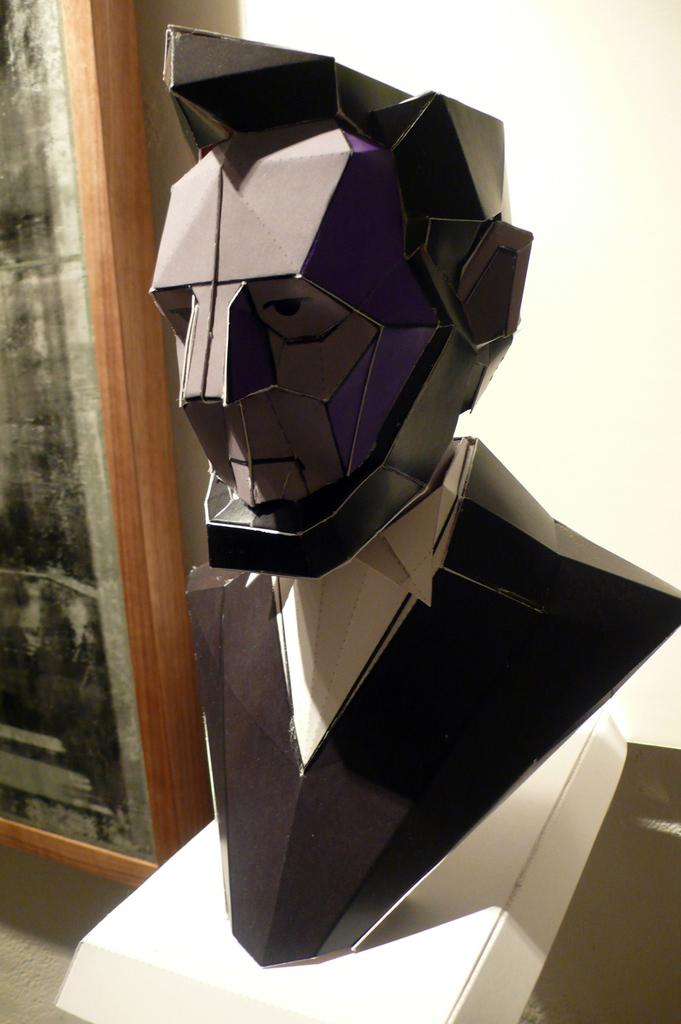What is the main subject in the image? There is a statue of a person in the image. What is the color scheme of the statue? The statue is in black and white color. What can be seen in the background of the image? There is a board and a wall in the background of the image. What type of songs can be heard coming from the statue in the image? There are no songs present in the image, as it features a statue that is not capable of producing sound. 